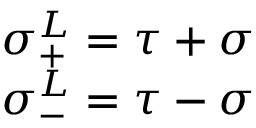<formula> <loc_0><loc_0><loc_500><loc_500>\begin{array} { l l } { { \sigma _ { + } ^ { L } = \tau + \sigma } } \\ { { \sigma _ { - } ^ { L } = \tau - \sigma } } \end{array}</formula> 